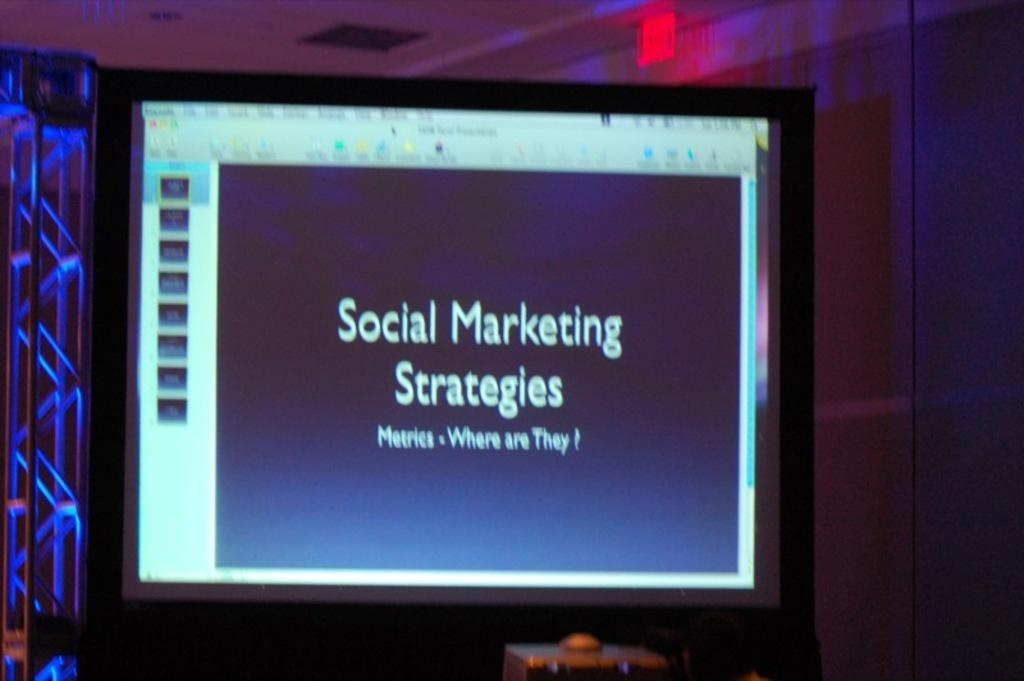<image>
Present a compact description of the photo's key features. a screen showing social marketing strategies for people 